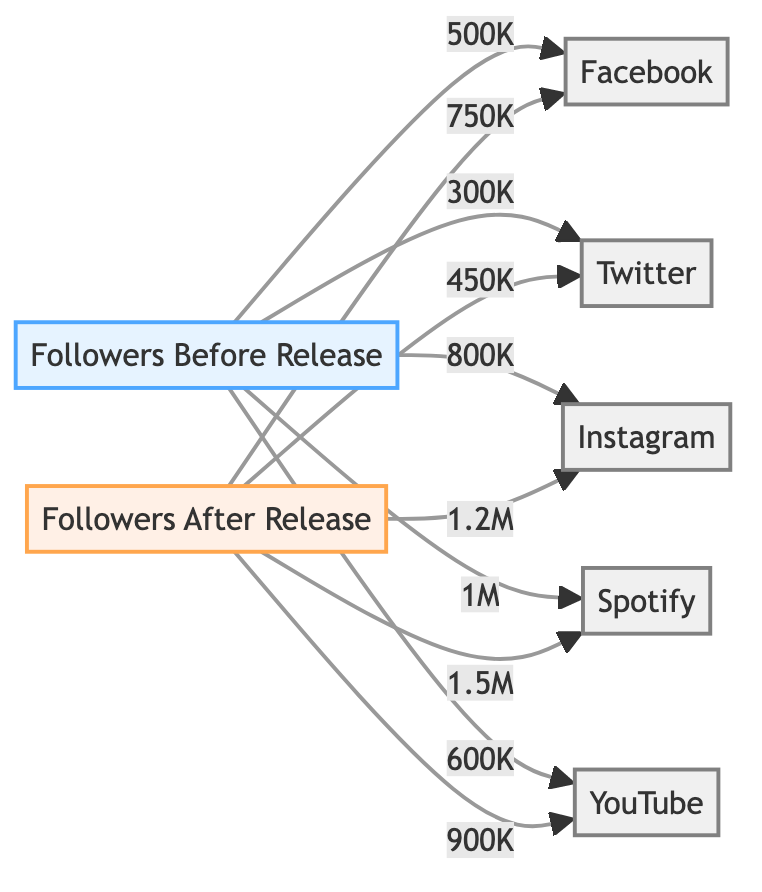What were the followers on Facebook before the release? The diagram indicates that the number of followers on Facebook before the release was 500K. This figure is represented directly in the node labeled "Followers Before Release" linked to the Facebook node.
Answer: 500K What is the increase in Instagram followers after the album release? To determine the increase, subtract the number of followers before the release (800K) from the number after the release (1.2M). Therefore, the increase is 1.2M - 800K = 400K.
Answer: 400K How many total platforms are represented in the diagram? The diagram includes five platforms: Facebook, Twitter, Instagram, Spotify, and YouTube. By counting each of these nodes, I confirm there are five platforms present.
Answer: 5 What was the number of Twitter followers after the release? According to the diagram, the number of followers on Twitter after the release is shown as 450K in the node linked to "Followers After Release" corresponding to the Twitter platform.
Answer: 450K What is the total increase across all platforms after the releases? To find the total increase across all platforms, we calculate the increases for each platform: Facebook (250K), Twitter (150K), Instagram (400K), Spotify (500K), and YouTube (300K). Adding these increases gives: 250K + 150K + 400K + 500K + 300K = 1.6M total increase.
Answer: 1.6M What were the total followers for Spotify before the release? The diagram specifies that for Spotify, the number of followers before the release is denoted as 1M according to the connection from "Followers Before Release" to the Spotify node.
Answer: 1M How does the number of YouTube followers compare before and after the release? The YouTube followers before the release were 600K, and after the release, they increased to 900K. This indicates a positive growth and can be deduced directly from the two connected nodes in the diagram highlighting the before and after figures.
Answer: Increased What color represents the followers' data before the release in the diagram? The data representing followers before the release is colored light blue, as indicated by the class definition associated with "Followers Before Release" in the diagram.
Answer: Light blue What percentage increase did Spotify experience from before to after the release? The calculation involves taking the increase from 1M to 1.5M, resulting in a 0.5M increase. To find the percentage increase, divide the increase by the original number: (0.5M / 1M) * 100% = 50%.
Answer: 50% 